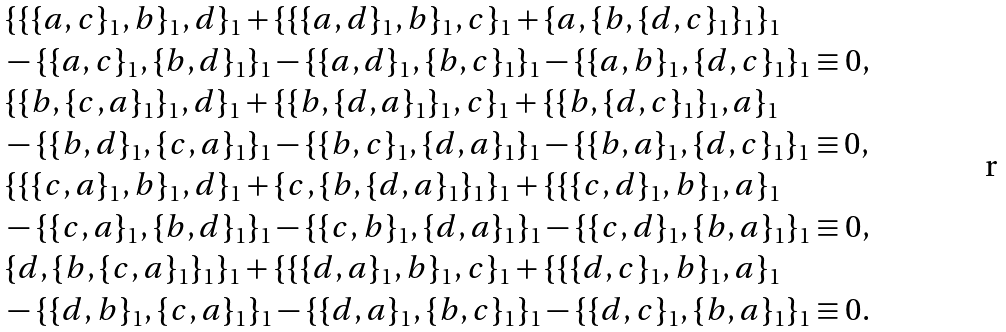<formula> <loc_0><loc_0><loc_500><loc_500>& \{ \{ \{ a , c \} _ { 1 } , b \} _ { 1 } , d \} _ { 1 } + \{ \{ \{ a , d \} _ { 1 } , b \} _ { 1 } , c \} _ { 1 } + \{ a , \{ b , \{ d , c \} _ { 1 } \} _ { 1 } \} _ { 1 } \\ & - \{ \{ a , c \} _ { 1 } , \{ b , d \} _ { 1 } \} _ { 1 } - \{ \{ a , d \} _ { 1 } , \{ b , c \} _ { 1 } \} _ { 1 } - \{ \{ a , b \} _ { 1 } , \{ d , c \} _ { 1 } \} _ { 1 } \equiv 0 , \\ & \{ \{ b , \{ c , a \} _ { 1 } \} _ { 1 } , d \} _ { 1 } + \{ \{ b , \{ d , a \} _ { 1 } \} _ { 1 } , c \} _ { 1 } + \{ \{ b , \{ d , c \} _ { 1 } \} _ { 1 } , a \} _ { 1 } \\ & - \{ \{ b , d \} _ { 1 } , \{ c , a \} _ { 1 } \} _ { 1 } - \{ \{ b , c \} _ { 1 } , \{ d , a \} _ { 1 } \} _ { 1 } - \{ \{ b , a \} _ { 1 } , \{ d , c \} _ { 1 } \} _ { 1 } \equiv 0 , \\ & \{ \{ \{ c , a \} _ { 1 } , b \} _ { 1 } , d \} _ { 1 } + \{ c , \{ b , \{ d , a \} _ { 1 } \} _ { 1 } \} _ { 1 } + \{ \{ \{ c , d \} _ { 1 } , b \} _ { 1 } , a \} _ { 1 } \\ & - \{ \{ c , a \} _ { 1 } , \{ b , d \} _ { 1 } \} _ { 1 } - \{ \{ c , b \} _ { 1 } , \{ d , a \} _ { 1 } \} _ { 1 } - \{ \{ c , d \} _ { 1 } , \{ b , a \} _ { 1 } \} _ { 1 } \equiv 0 , \\ & \{ d , \{ b , \{ c , a \} _ { 1 } \} _ { 1 } \} _ { 1 } + \{ \{ \{ d , a \} _ { 1 } , b \} _ { 1 } , c \} _ { 1 } + \{ \{ \{ d , c \} _ { 1 } , b \} _ { 1 } , a \} _ { 1 } \\ & - \{ \{ d , b \} _ { 1 } , \{ c , a \} _ { 1 } \} _ { 1 } - \{ \{ d , a \} _ { 1 } , \{ b , c \} _ { 1 } \} _ { 1 } - \{ \{ d , c \} _ { 1 } , \{ b , a \} _ { 1 } \} _ { 1 } \equiv 0 .</formula> 